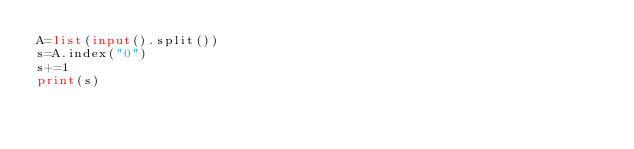Convert code to text. <code><loc_0><loc_0><loc_500><loc_500><_Python_>A=list(input().split())
s=A.index("0")
s+=1
print(s)</code> 